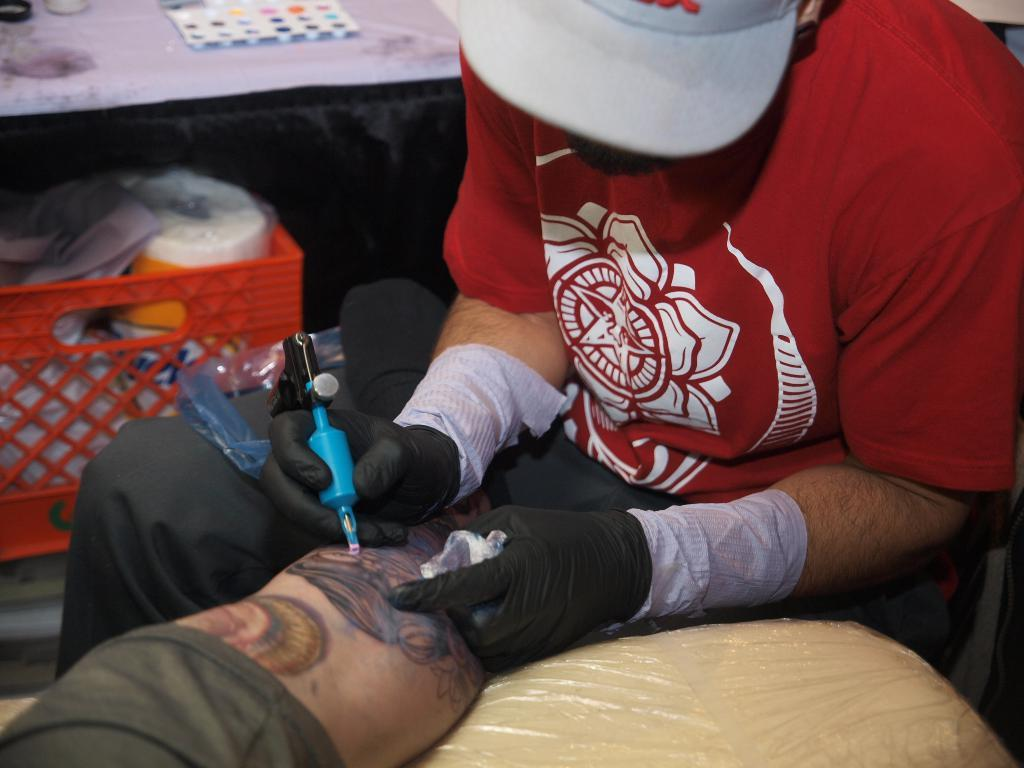How many people are in the image? There are two persons in the image. Can you describe one of the persons? One of the persons is a man, who is wearing a cap and gloves. What is the man holding in his hand? The man is holding an object in his hand, but the specific object is not mentioned in the facts. What can be seen in the background of the image? There is a basket in the background of the image. What is inside the basket? The basket contains some objects, but the specific objects are not mentioned in the facts. What riddle does the man ask the other person in the image? There is no mention of a riddle or any verbal interaction between the two persons in the image. How many hands does the man have in the image? The man has two hands, as is typical for humans. 